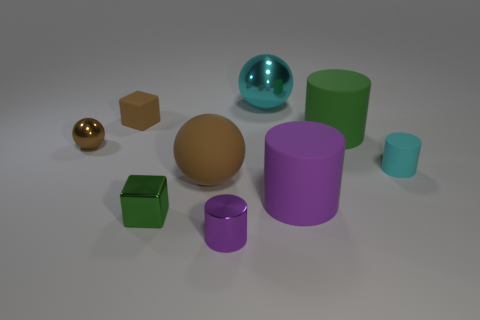Add 1 gray blocks. How many objects exist? 10 Subtract all cylinders. How many objects are left? 5 Add 5 purple cylinders. How many purple cylinders exist? 7 Subtract 0 purple balls. How many objects are left? 9 Subtract all matte things. Subtract all brown shiny balls. How many objects are left? 3 Add 9 cyan rubber objects. How many cyan rubber objects are left? 10 